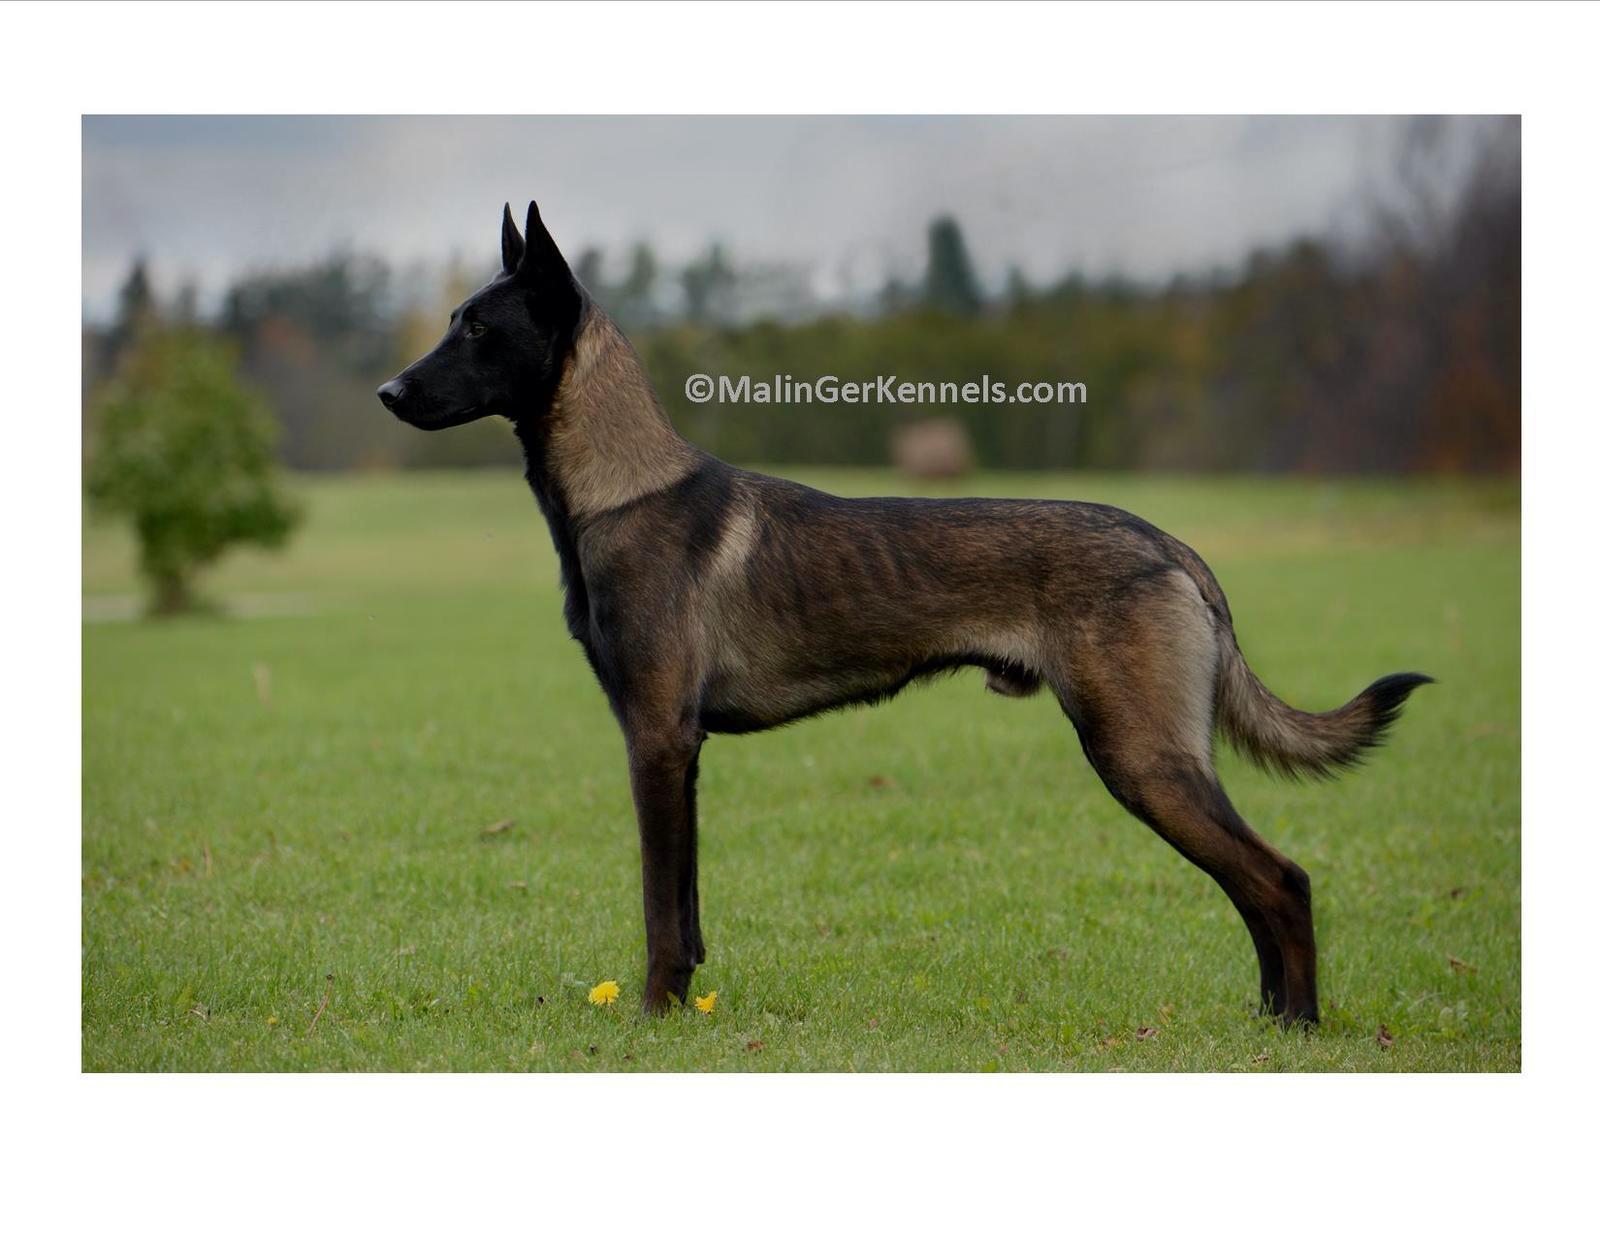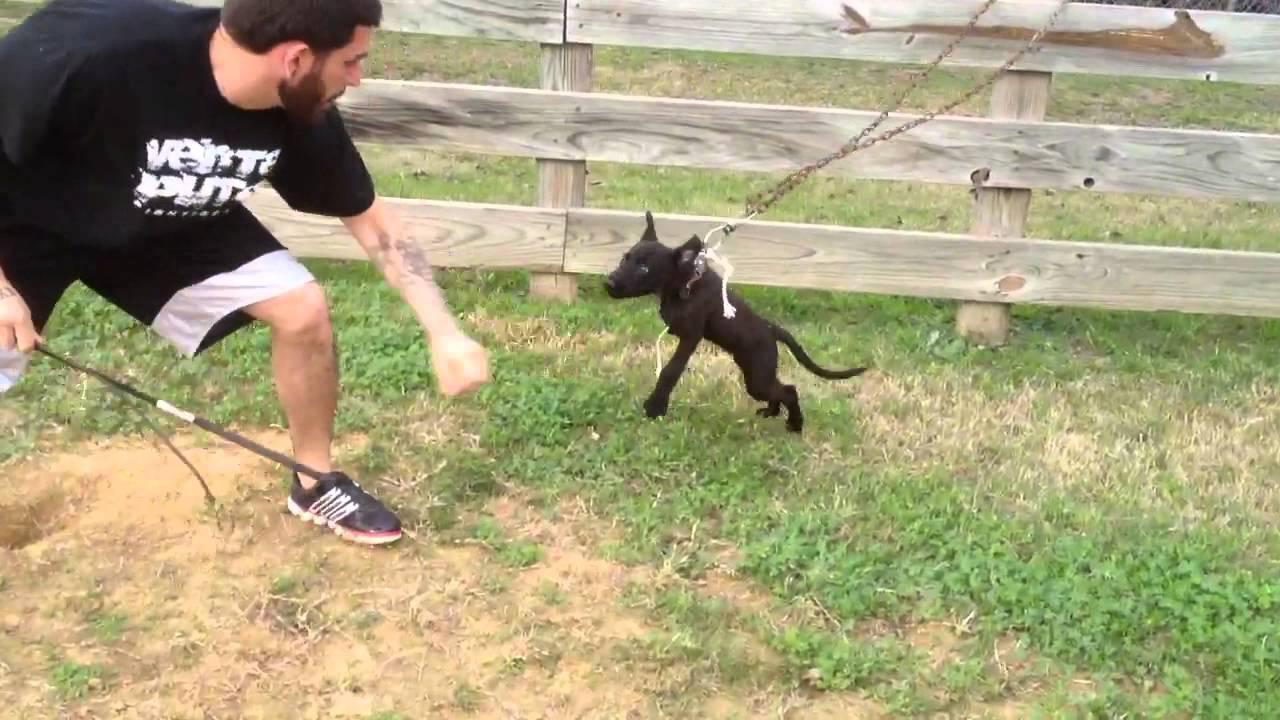The first image is the image on the left, the second image is the image on the right. For the images shown, is this caption "An image shows a dog running toward the camera and facing forward." true? Answer yes or no. No. The first image is the image on the left, the second image is the image on the right. Evaluate the accuracy of this statement regarding the images: "At least one dog is running toward the camera.". Is it true? Answer yes or no. No. 